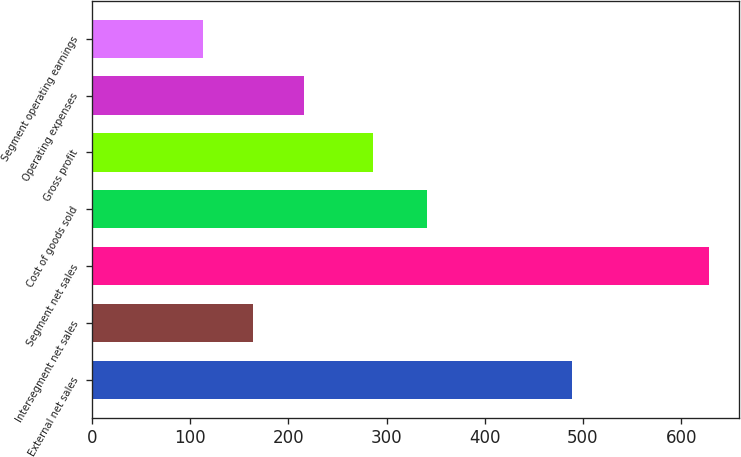Convert chart to OTSL. <chart><loc_0><loc_0><loc_500><loc_500><bar_chart><fcel>External net sales<fcel>Intersegment net sales<fcel>Segment net sales<fcel>Cost of goods sold<fcel>Gross profit<fcel>Operating expenses<fcel>Segment operating earnings<nl><fcel>488.8<fcel>164.39<fcel>627.8<fcel>341.1<fcel>286.7<fcel>215.88<fcel>112.9<nl></chart> 